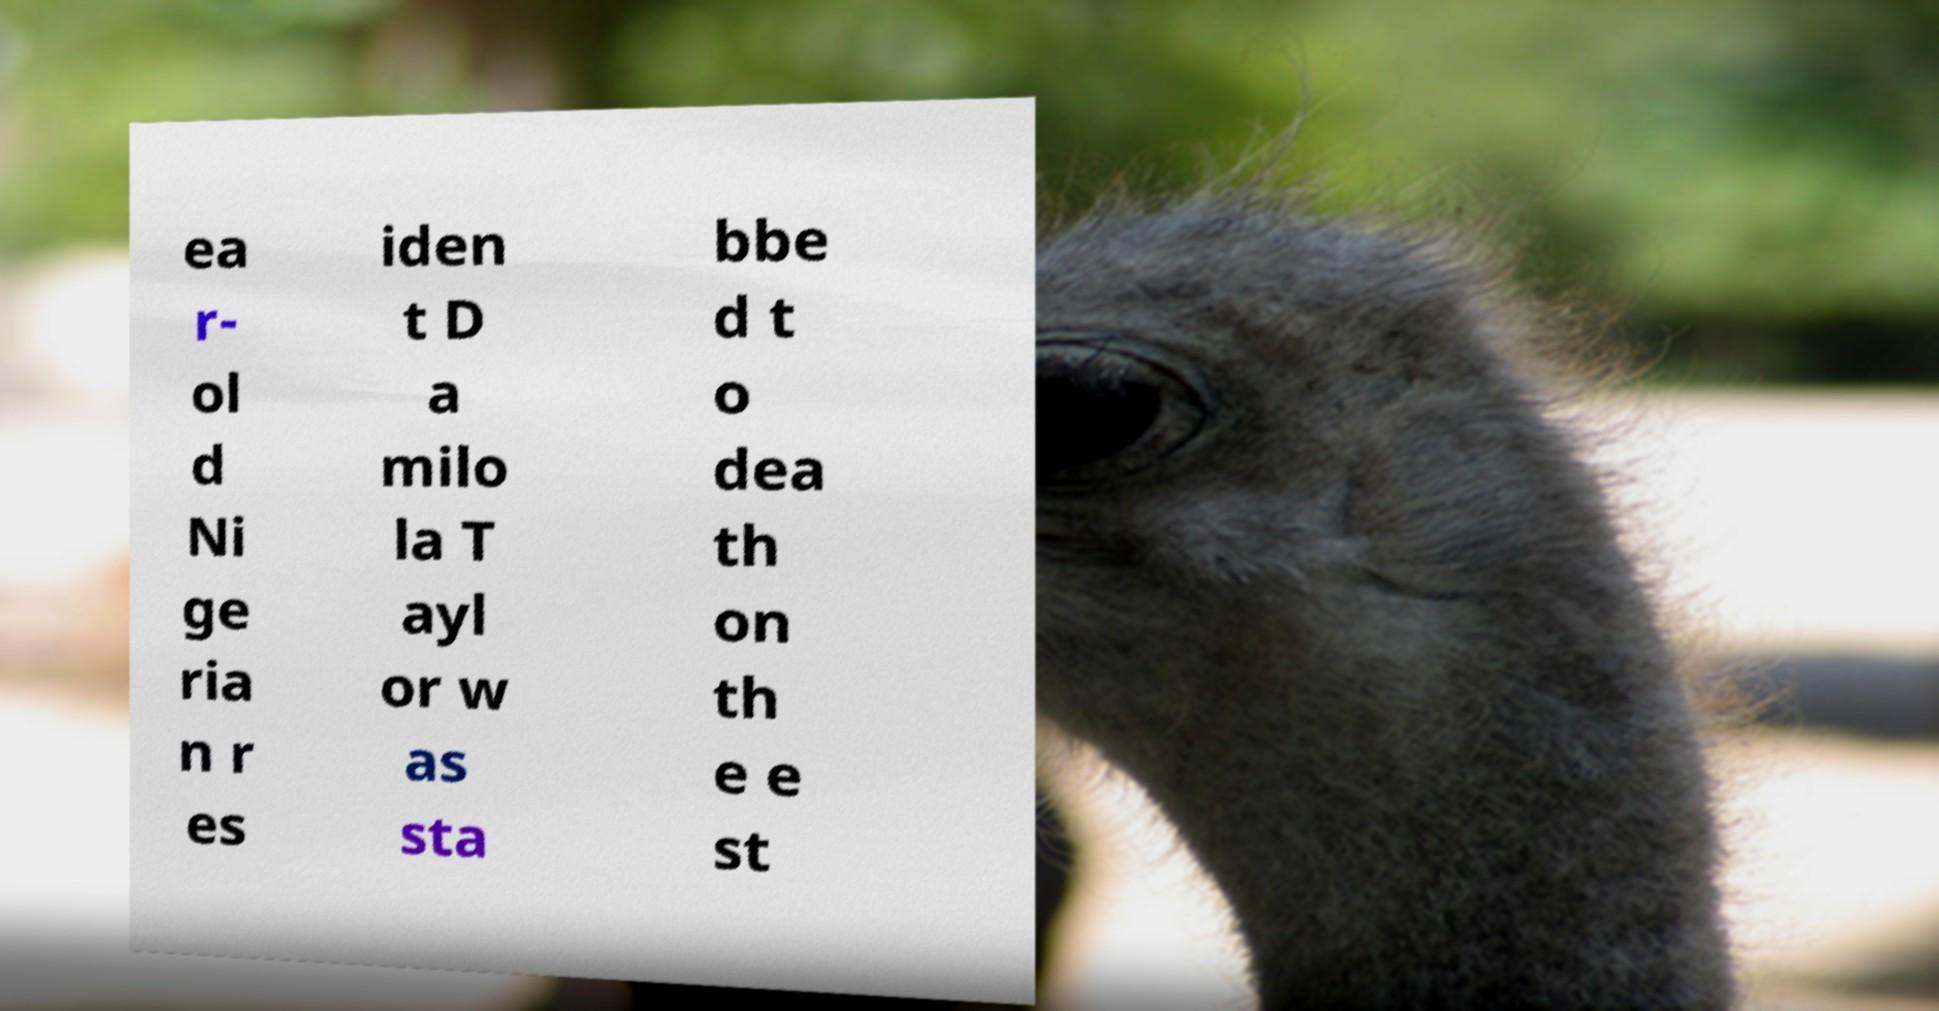What messages or text are displayed in this image? I need them in a readable, typed format. ea r- ol d Ni ge ria n r es iden t D a milo la T ayl or w as sta bbe d t o dea th on th e e st 